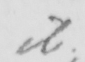Please provide the text content of this handwritten line. ib . 